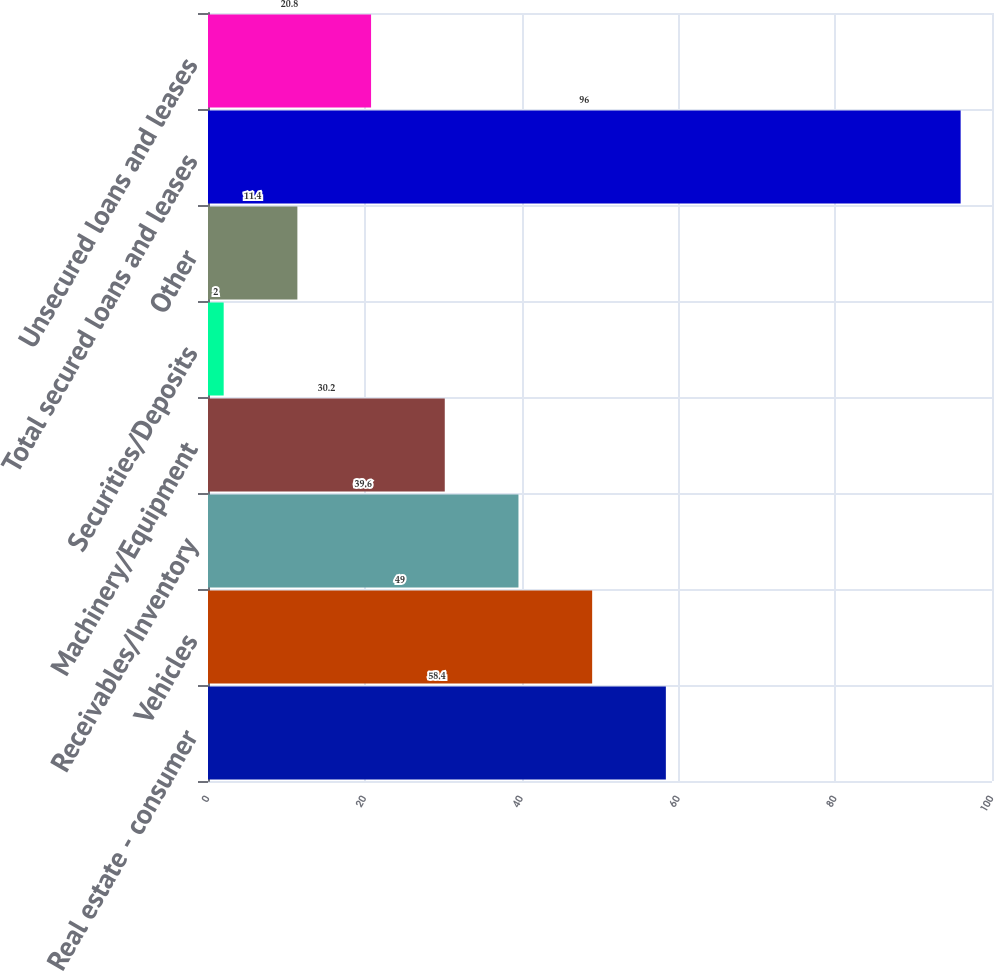<chart> <loc_0><loc_0><loc_500><loc_500><bar_chart><fcel>Real estate - consumer<fcel>Vehicles<fcel>Receivables/Inventory<fcel>Machinery/Equipment<fcel>Securities/Deposits<fcel>Other<fcel>Total secured loans and leases<fcel>Unsecured loans and leases<nl><fcel>58.4<fcel>49<fcel>39.6<fcel>30.2<fcel>2<fcel>11.4<fcel>96<fcel>20.8<nl></chart> 